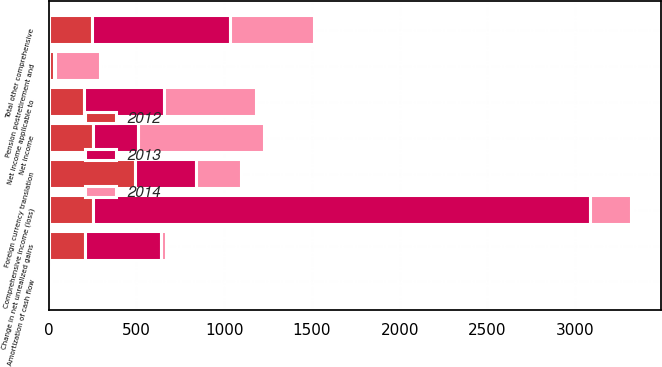Convert chart to OTSL. <chart><loc_0><loc_0><loc_500><loc_500><stacked_bar_chart><ecel><fcel>Net income<fcel>Foreign currency translation<fcel>Amortization of cash flow<fcel>Change in net unrealized gains<fcel>Pension postretirement and<fcel>Total other comprehensive<fcel>Comprehensive income (loss)<fcel>Net income applicable to<nl><fcel>2012<fcel>255<fcel>491<fcel>4<fcel>209<fcel>29<fcel>249<fcel>255<fcel>200<nl><fcel>2013<fcel>255<fcel>348<fcel>4<fcel>433<fcel>5<fcel>782<fcel>2831<fcel>459<nl><fcel>2014<fcel>716<fcel>255<fcel>6<fcel>28<fcel>260<fcel>481<fcel>235<fcel>524<nl></chart> 